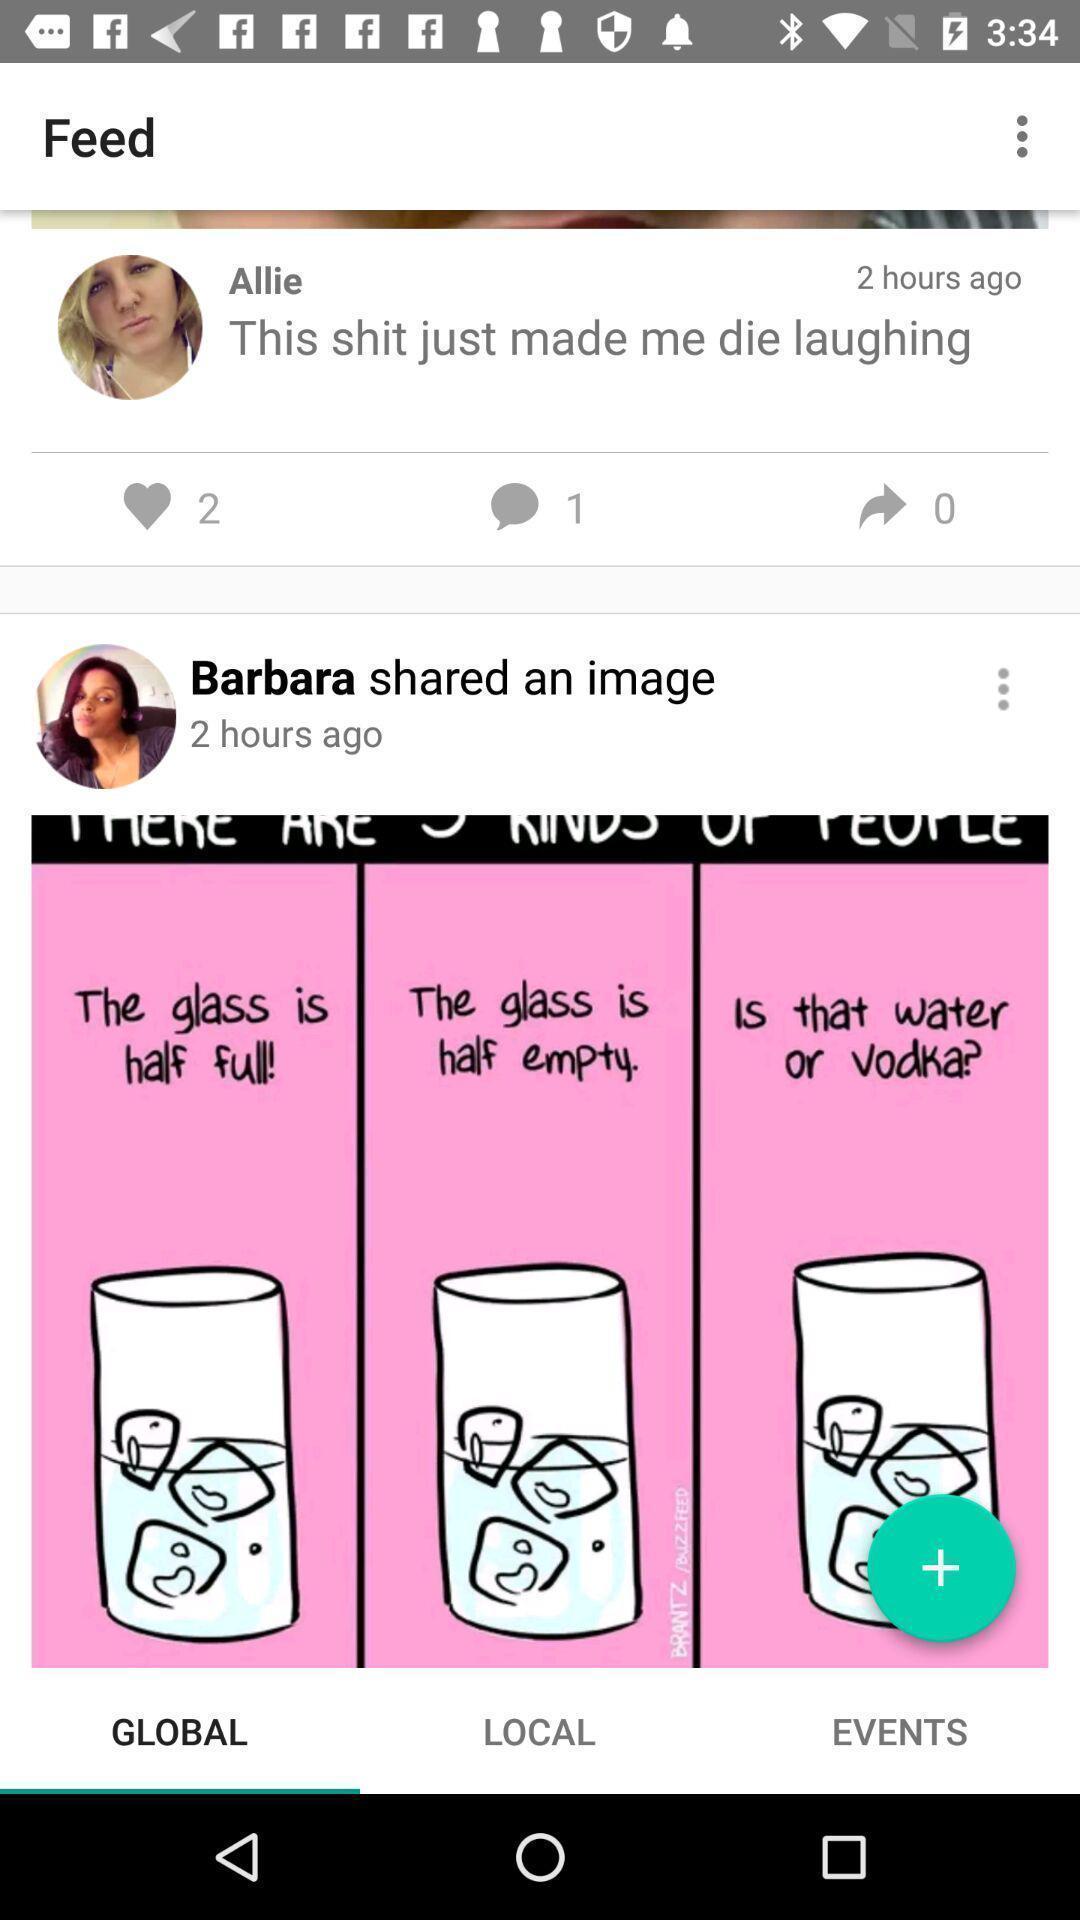Tell me about the visual elements in this screen capture. Screen page displaying different options in social app. 